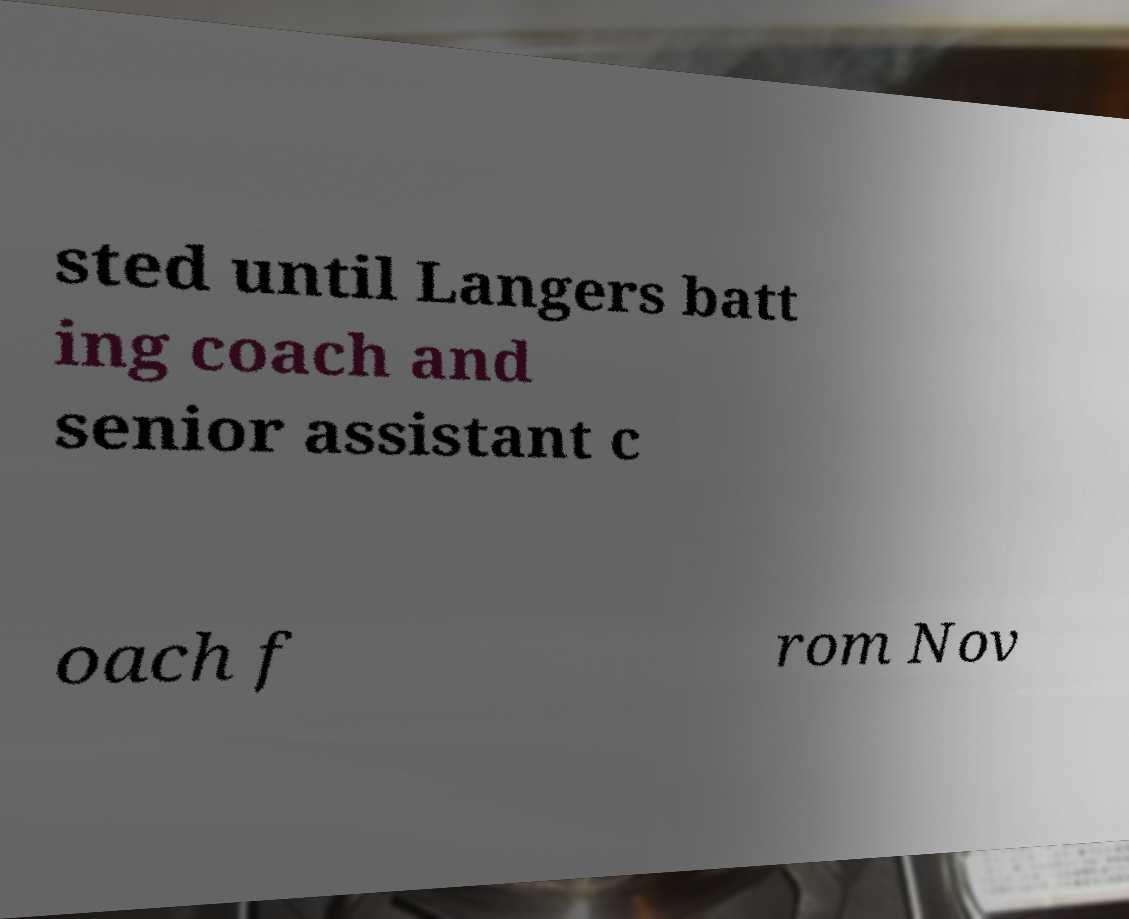Could you assist in decoding the text presented in this image and type it out clearly? sted until Langers batt ing coach and senior assistant c oach f rom Nov 